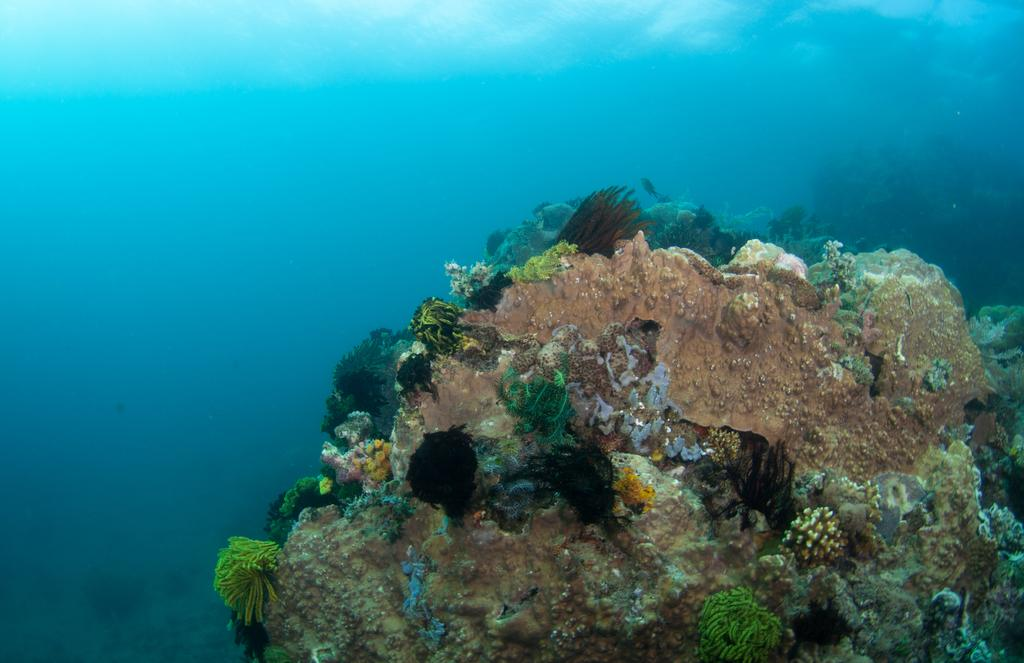What type of plants can be seen in the image? There are sea plants in the image. What else is present in the water besides the sea plants? There is algae in the image. Can you describe the environment in which the sea plants and algae are located? Both the sea plants and algae are in the water. What type of fish can be seen rolling in the image? There are no fish present in the image, and no rolling activity is depicted. 